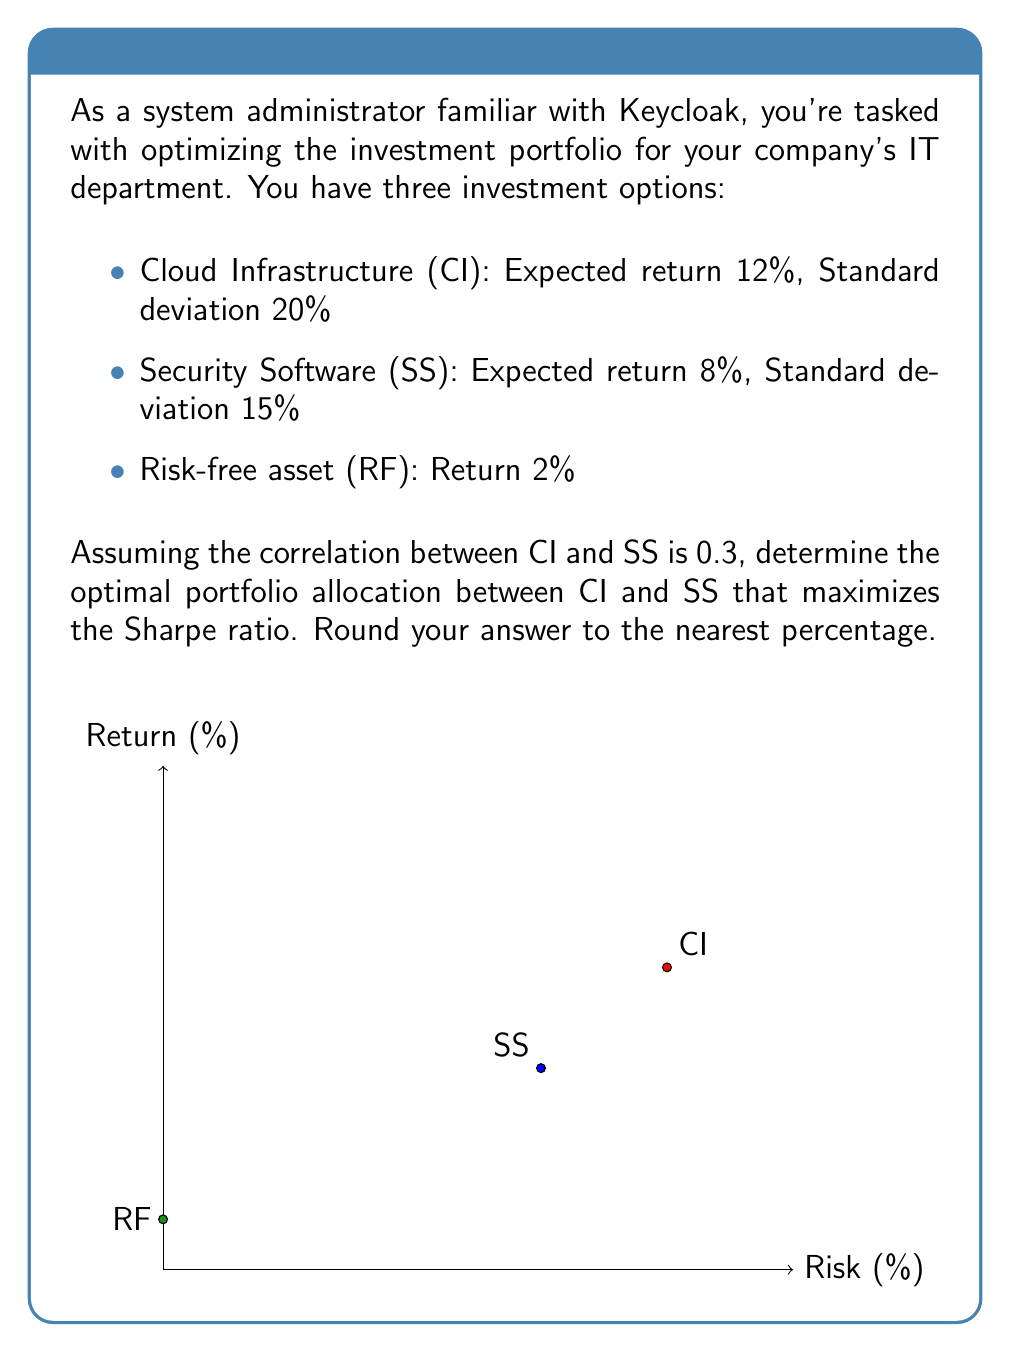Show me your answer to this math problem. To solve this problem, we'll follow these steps:

1. Calculate the portfolio variance for different weightings
2. Calculate the portfolio expected return for different weightings
3. Calculate the Sharpe ratio for each weighting
4. Find the weighting that maximizes the Sharpe ratio

Step 1: Portfolio variance
The formula for portfolio variance with two assets is:
$$\sigma_p^2 = w_1^2\sigma_1^2 + w_2^2\sigma_2^2 + 2w_1w_2\sigma_1\sigma_2\rho_{12}$$

Where:
$w_1$ is the weight of CI
$w_2 = 1 - w_1$ is the weight of SS
$\sigma_1 = 20\%$, $\sigma_2 = 15\%$, and $\rho_{12} = 0.3$

Step 2: Portfolio expected return
$$E(R_p) = w_1E(R_1) + w_2E(R_2)$$

Where $E(R_1) = 12\%$ and $E(R_2) = 8\%$

Step 3: Sharpe ratio
The Sharpe ratio is calculated as:
$$SR = \frac{E(R_p) - R_f}{\sigma_p}$$

Where $R_f = 2\%$

Step 4: Maximize Sharpe ratio
We can use a spreadsheet or programming language to iterate through different weightings and find the maximum Sharpe ratio. Here's a sample of calculations:

| CI Weight | SS Weight | Portfolio Return | Portfolio StDev | Sharpe Ratio |
|-----------|-----------|-------------------|-----------------|--------------|
| 0%        | 100%      | 8.00%             | 15.00%          | 0.400        |
| 20%       | 80%       | 8.80%             | 13.76%          | 0.495        |
| 40%       | 60%       | 9.60%             | 13.93%          | 0.545        |
| 60%       | 40%       | 10.40%            | 15.39%          | 0.545        |
| 80%       | 20%       | 11.20%            | 17.69%          | 0.519        |
| 100%      | 0%        | 12.00%            | 20.00%          | 0.500        |

The maximum Sharpe ratio occurs when the weight of CI is approximately 52% and SS is 48%.
Answer: CI: 52%, SS: 48% 